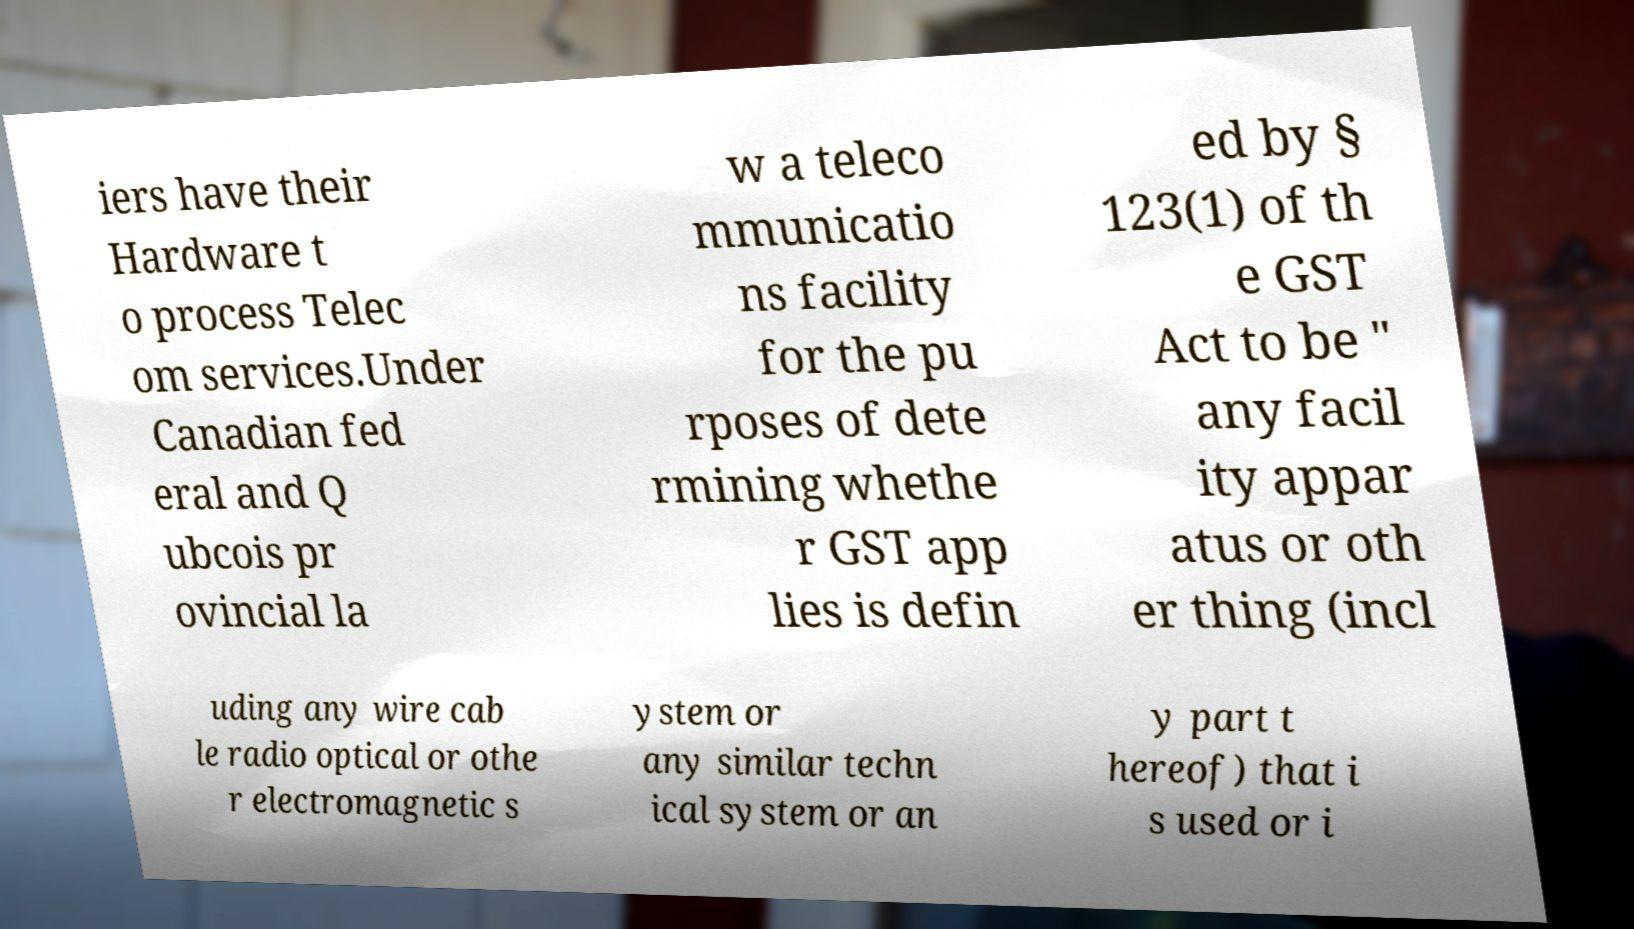For documentation purposes, I need the text within this image transcribed. Could you provide that? iers have their Hardware t o process Telec om services.Under Canadian fed eral and Q ubcois pr ovincial la w a teleco mmunicatio ns facility for the pu rposes of dete rmining whethe r GST app lies is defin ed by § 123(1) of th e GST Act to be " any facil ity appar atus or oth er thing (incl uding any wire cab le radio optical or othe r electromagnetic s ystem or any similar techn ical system or an y part t hereof) that i s used or i 